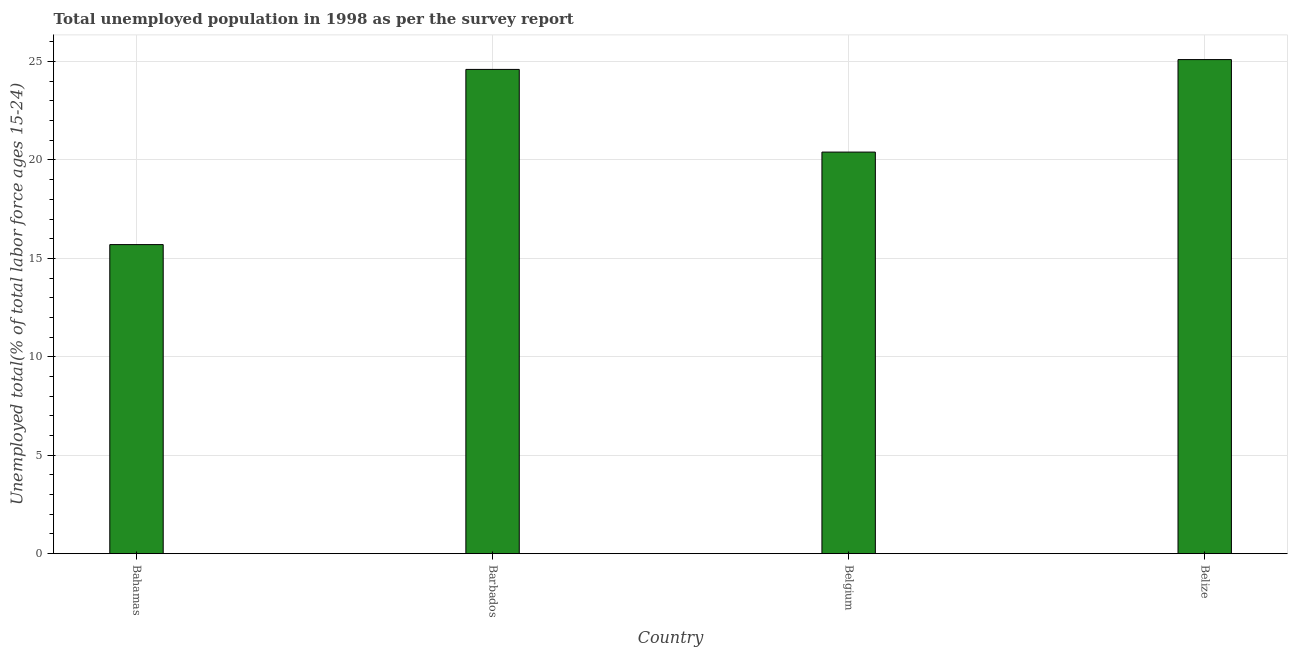Does the graph contain any zero values?
Your answer should be very brief. No. What is the title of the graph?
Offer a very short reply. Total unemployed population in 1998 as per the survey report. What is the label or title of the Y-axis?
Offer a very short reply. Unemployed total(% of total labor force ages 15-24). What is the unemployed youth in Barbados?
Offer a terse response. 24.6. Across all countries, what is the maximum unemployed youth?
Make the answer very short. 25.1. Across all countries, what is the minimum unemployed youth?
Offer a very short reply. 15.7. In which country was the unemployed youth maximum?
Ensure brevity in your answer.  Belize. In which country was the unemployed youth minimum?
Provide a short and direct response. Bahamas. What is the sum of the unemployed youth?
Offer a very short reply. 85.8. What is the average unemployed youth per country?
Provide a short and direct response. 21.45. What is the median unemployed youth?
Provide a short and direct response. 22.5. Is the sum of the unemployed youth in Bahamas and Barbados greater than the maximum unemployed youth across all countries?
Provide a short and direct response. Yes. How many countries are there in the graph?
Provide a short and direct response. 4. What is the difference between two consecutive major ticks on the Y-axis?
Provide a succinct answer. 5. Are the values on the major ticks of Y-axis written in scientific E-notation?
Your answer should be very brief. No. What is the Unemployed total(% of total labor force ages 15-24) of Bahamas?
Give a very brief answer. 15.7. What is the Unemployed total(% of total labor force ages 15-24) of Barbados?
Offer a terse response. 24.6. What is the Unemployed total(% of total labor force ages 15-24) of Belgium?
Offer a terse response. 20.4. What is the Unemployed total(% of total labor force ages 15-24) of Belize?
Provide a succinct answer. 25.1. What is the difference between the Unemployed total(% of total labor force ages 15-24) in Barbados and Belgium?
Ensure brevity in your answer.  4.2. What is the ratio of the Unemployed total(% of total labor force ages 15-24) in Bahamas to that in Barbados?
Give a very brief answer. 0.64. What is the ratio of the Unemployed total(% of total labor force ages 15-24) in Bahamas to that in Belgium?
Your answer should be very brief. 0.77. What is the ratio of the Unemployed total(% of total labor force ages 15-24) in Barbados to that in Belgium?
Keep it short and to the point. 1.21. What is the ratio of the Unemployed total(% of total labor force ages 15-24) in Barbados to that in Belize?
Keep it short and to the point. 0.98. What is the ratio of the Unemployed total(% of total labor force ages 15-24) in Belgium to that in Belize?
Offer a terse response. 0.81. 